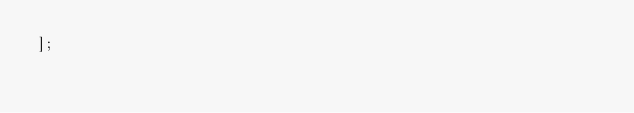<code> <loc_0><loc_0><loc_500><loc_500><_JavaScript_>];
</code> 